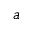Convert formula to latex. <formula><loc_0><loc_0><loc_500><loc_500>a</formula> 